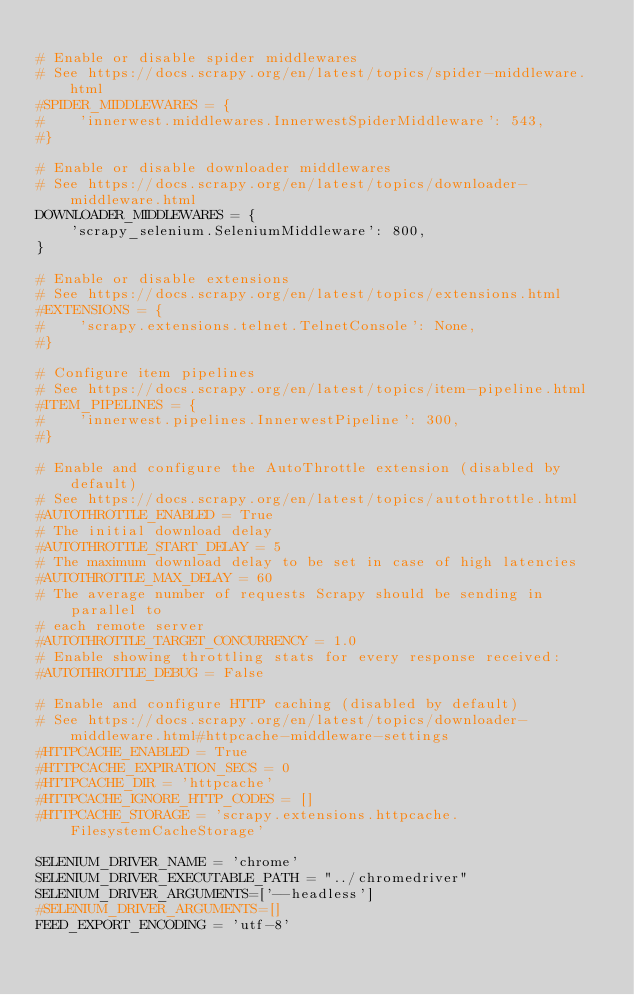<code> <loc_0><loc_0><loc_500><loc_500><_Python_>
# Enable or disable spider middlewares
# See https://docs.scrapy.org/en/latest/topics/spider-middleware.html
#SPIDER_MIDDLEWARES = {
#    'innerwest.middlewares.InnerwestSpiderMiddleware': 543,
#}

# Enable or disable downloader middlewares
# See https://docs.scrapy.org/en/latest/topics/downloader-middleware.html
DOWNLOADER_MIDDLEWARES = {
    'scrapy_selenium.SeleniumMiddleware': 800,
}

# Enable or disable extensions
# See https://docs.scrapy.org/en/latest/topics/extensions.html
#EXTENSIONS = {
#    'scrapy.extensions.telnet.TelnetConsole': None,
#}

# Configure item pipelines
# See https://docs.scrapy.org/en/latest/topics/item-pipeline.html
#ITEM_PIPELINES = {
#    'innerwest.pipelines.InnerwestPipeline': 300,
#}

# Enable and configure the AutoThrottle extension (disabled by default)
# See https://docs.scrapy.org/en/latest/topics/autothrottle.html
#AUTOTHROTTLE_ENABLED = True
# The initial download delay
#AUTOTHROTTLE_START_DELAY = 5
# The maximum download delay to be set in case of high latencies
#AUTOTHROTTLE_MAX_DELAY = 60
# The average number of requests Scrapy should be sending in parallel to
# each remote server
#AUTOTHROTTLE_TARGET_CONCURRENCY = 1.0
# Enable showing throttling stats for every response received:
#AUTOTHROTTLE_DEBUG = False

# Enable and configure HTTP caching (disabled by default)
# See https://docs.scrapy.org/en/latest/topics/downloader-middleware.html#httpcache-middleware-settings
#HTTPCACHE_ENABLED = True
#HTTPCACHE_EXPIRATION_SECS = 0
#HTTPCACHE_DIR = 'httpcache'
#HTTPCACHE_IGNORE_HTTP_CODES = []
#HTTPCACHE_STORAGE = 'scrapy.extensions.httpcache.FilesystemCacheStorage'

SELENIUM_DRIVER_NAME = 'chrome'
SELENIUM_DRIVER_EXECUTABLE_PATH = "../chromedriver"
SELENIUM_DRIVER_ARGUMENTS=['--headless']
#SELENIUM_DRIVER_ARGUMENTS=[]
FEED_EXPORT_ENCODING = 'utf-8'</code> 